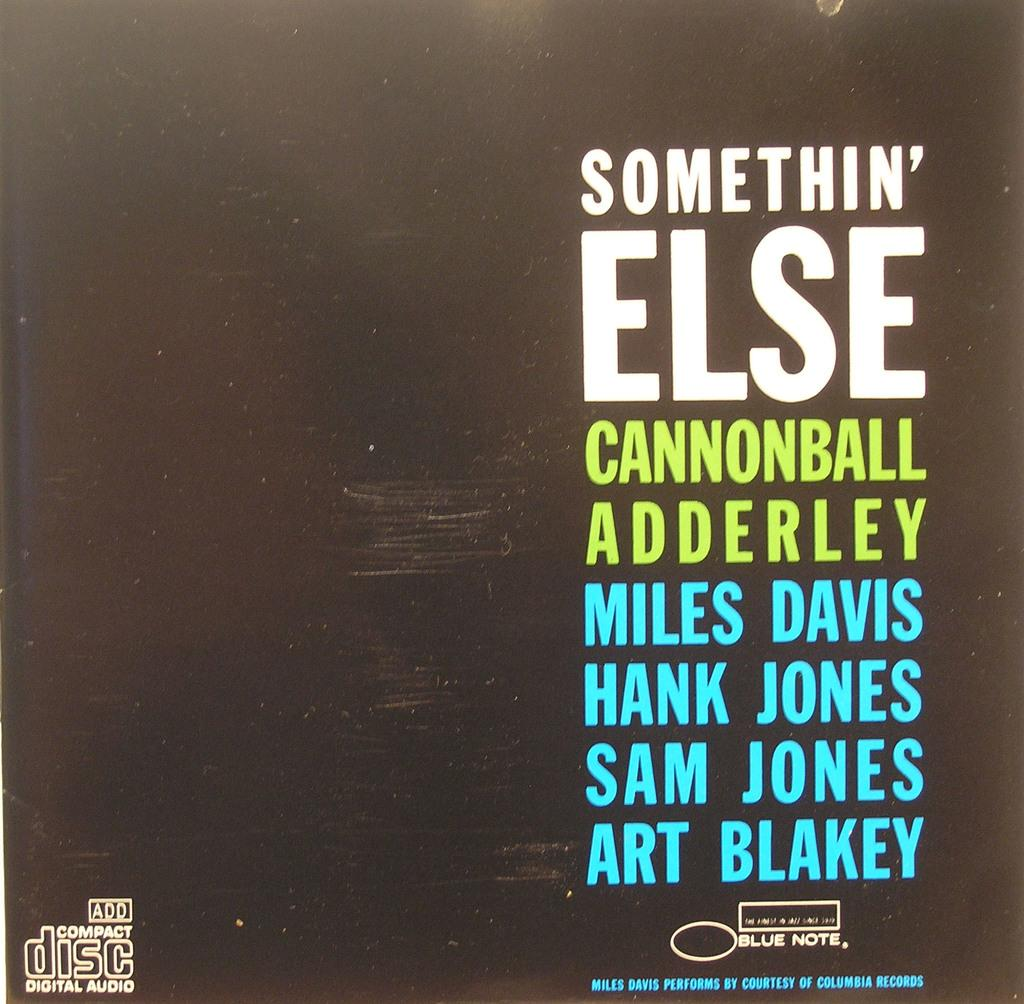Provide a one-sentence caption for the provided image. A compact disc compilation features artists like Miles Davis, Hank Jones, and Sam Jones. 